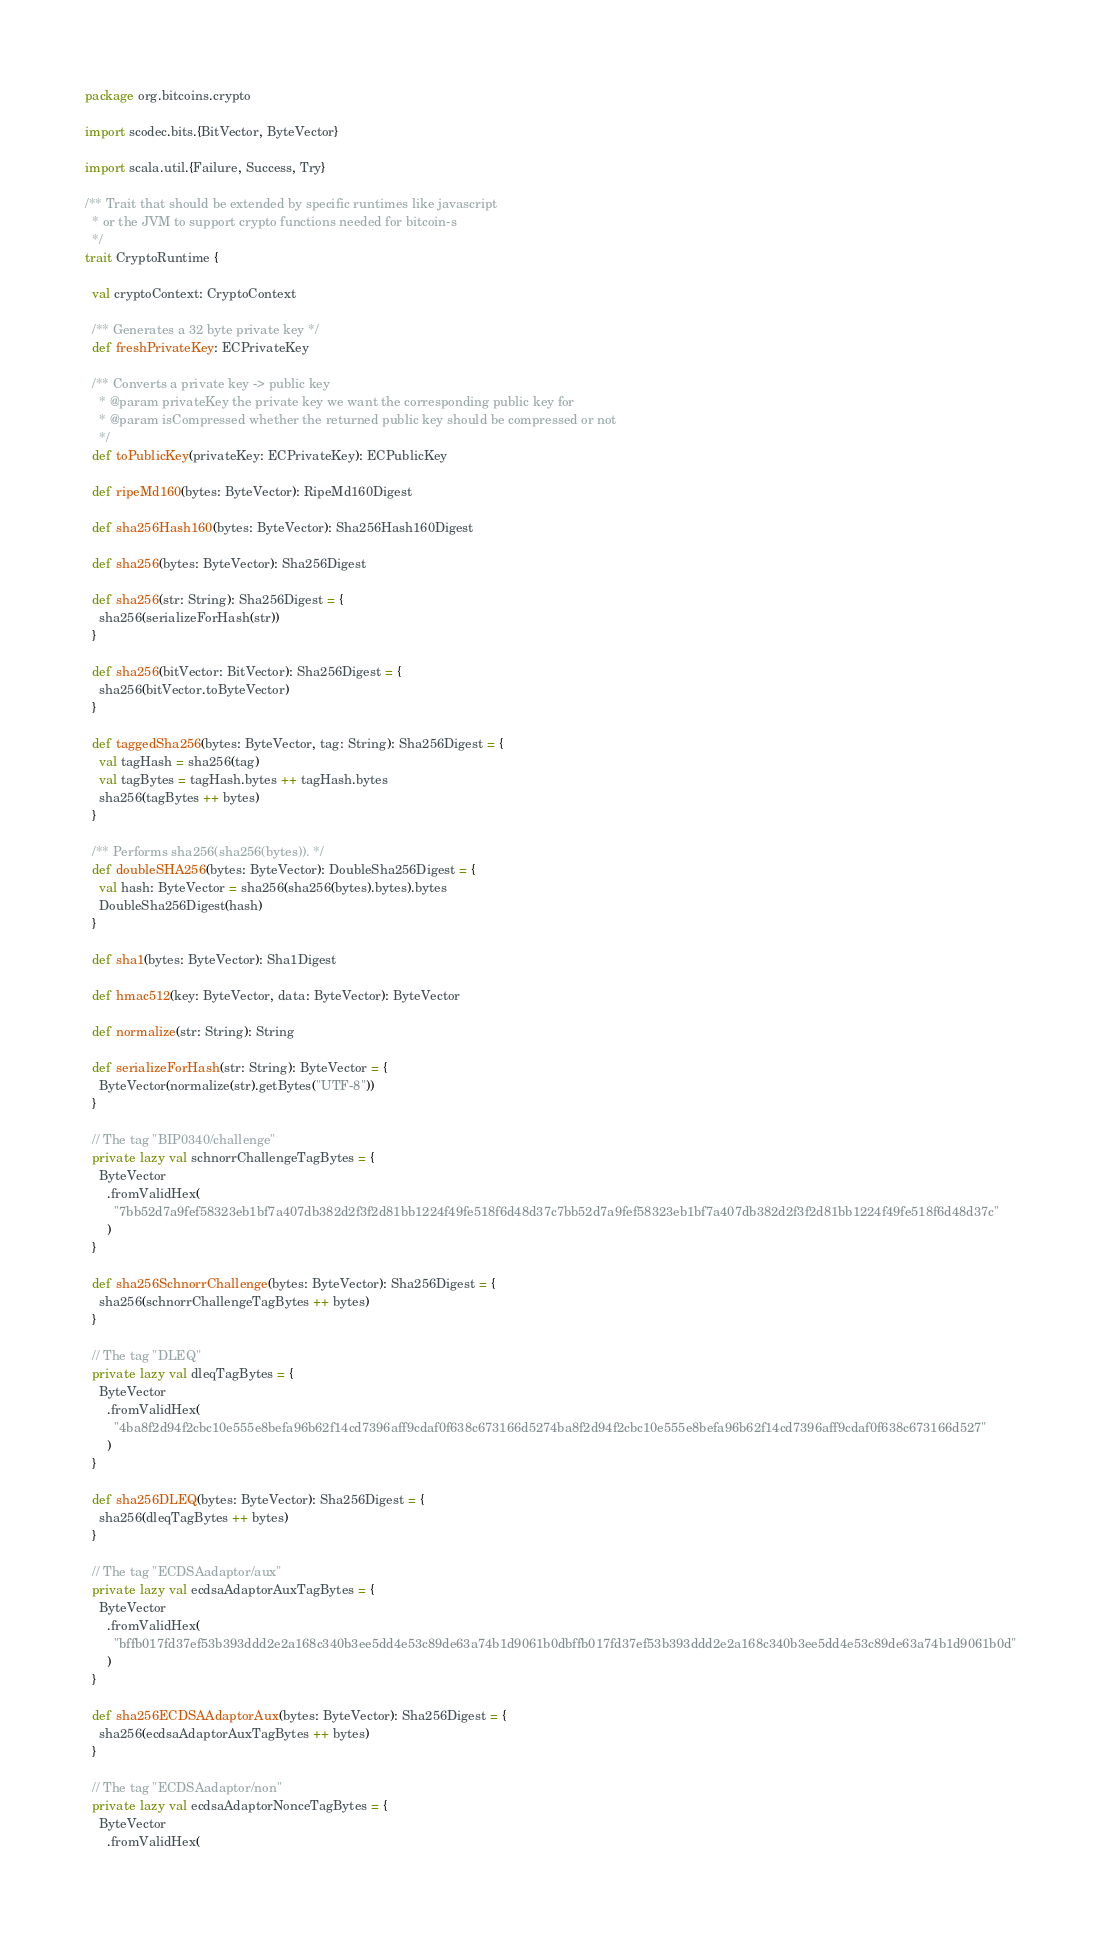<code> <loc_0><loc_0><loc_500><loc_500><_Scala_>package org.bitcoins.crypto

import scodec.bits.{BitVector, ByteVector}

import scala.util.{Failure, Success, Try}

/** Trait that should be extended by specific runtimes like javascript
  * or the JVM to support crypto functions needed for bitcoin-s
  */
trait CryptoRuntime {

  val cryptoContext: CryptoContext

  /** Generates a 32 byte private key */
  def freshPrivateKey: ECPrivateKey

  /** Converts a private key -> public key
    * @param privateKey the private key we want the corresponding public key for
    * @param isCompressed whether the returned public key should be compressed or not
    */
  def toPublicKey(privateKey: ECPrivateKey): ECPublicKey

  def ripeMd160(bytes: ByteVector): RipeMd160Digest

  def sha256Hash160(bytes: ByteVector): Sha256Hash160Digest

  def sha256(bytes: ByteVector): Sha256Digest

  def sha256(str: String): Sha256Digest = {
    sha256(serializeForHash(str))
  }

  def sha256(bitVector: BitVector): Sha256Digest = {
    sha256(bitVector.toByteVector)
  }

  def taggedSha256(bytes: ByteVector, tag: String): Sha256Digest = {
    val tagHash = sha256(tag)
    val tagBytes = tagHash.bytes ++ tagHash.bytes
    sha256(tagBytes ++ bytes)
  }

  /** Performs sha256(sha256(bytes)). */
  def doubleSHA256(bytes: ByteVector): DoubleSha256Digest = {
    val hash: ByteVector = sha256(sha256(bytes).bytes).bytes
    DoubleSha256Digest(hash)
  }

  def sha1(bytes: ByteVector): Sha1Digest

  def hmac512(key: ByteVector, data: ByteVector): ByteVector

  def normalize(str: String): String

  def serializeForHash(str: String): ByteVector = {
    ByteVector(normalize(str).getBytes("UTF-8"))
  }

  // The tag "BIP0340/challenge"
  private lazy val schnorrChallengeTagBytes = {
    ByteVector
      .fromValidHex(
        "7bb52d7a9fef58323eb1bf7a407db382d2f3f2d81bb1224f49fe518f6d48d37c7bb52d7a9fef58323eb1bf7a407db382d2f3f2d81bb1224f49fe518f6d48d37c"
      )
  }

  def sha256SchnorrChallenge(bytes: ByteVector): Sha256Digest = {
    sha256(schnorrChallengeTagBytes ++ bytes)
  }

  // The tag "DLEQ"
  private lazy val dleqTagBytes = {
    ByteVector
      .fromValidHex(
        "4ba8f2d94f2cbc10e555e8befa96b62f14cd7396aff9cdaf0f638c673166d5274ba8f2d94f2cbc10e555e8befa96b62f14cd7396aff9cdaf0f638c673166d527"
      )
  }

  def sha256DLEQ(bytes: ByteVector): Sha256Digest = {
    sha256(dleqTagBytes ++ bytes)
  }

  // The tag "ECDSAadaptor/aux"
  private lazy val ecdsaAdaptorAuxTagBytes = {
    ByteVector
      .fromValidHex(
        "bffb017fd37ef53b393ddd2e2a168c340b3ee5dd4e53c89de63a74b1d9061b0dbffb017fd37ef53b393ddd2e2a168c340b3ee5dd4e53c89de63a74b1d9061b0d"
      )
  }

  def sha256ECDSAAdaptorAux(bytes: ByteVector): Sha256Digest = {
    sha256(ecdsaAdaptorAuxTagBytes ++ bytes)
  }

  // The tag "ECDSAadaptor/non"
  private lazy val ecdsaAdaptorNonceTagBytes = {
    ByteVector
      .fromValidHex(</code> 